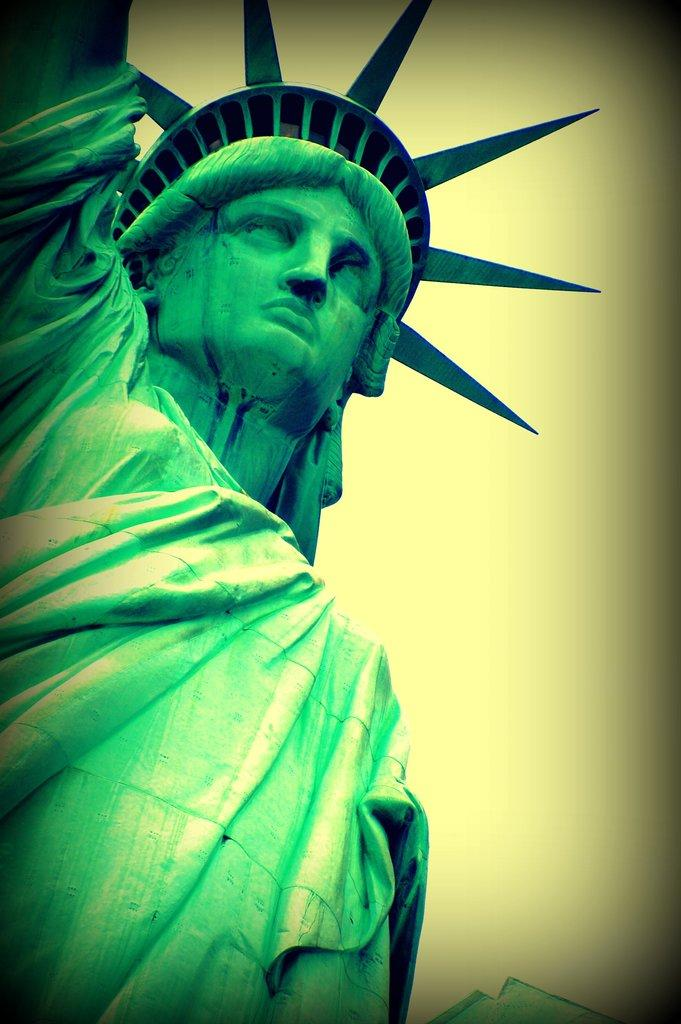What famous landmark is visible in the image? The Statue of Liberty is visible in the image. What is the color of the background in the image? The background has a yellow color. How many pies is the grandmother holding in the image? There is no grandmother or pies present in the image; it features the Statue of Liberty with a yellow background. In which direction is the Statue of Liberty facing in the image? The direction the Statue of Liberty is facing cannot be determined from the image alone, as it is a static structure. 